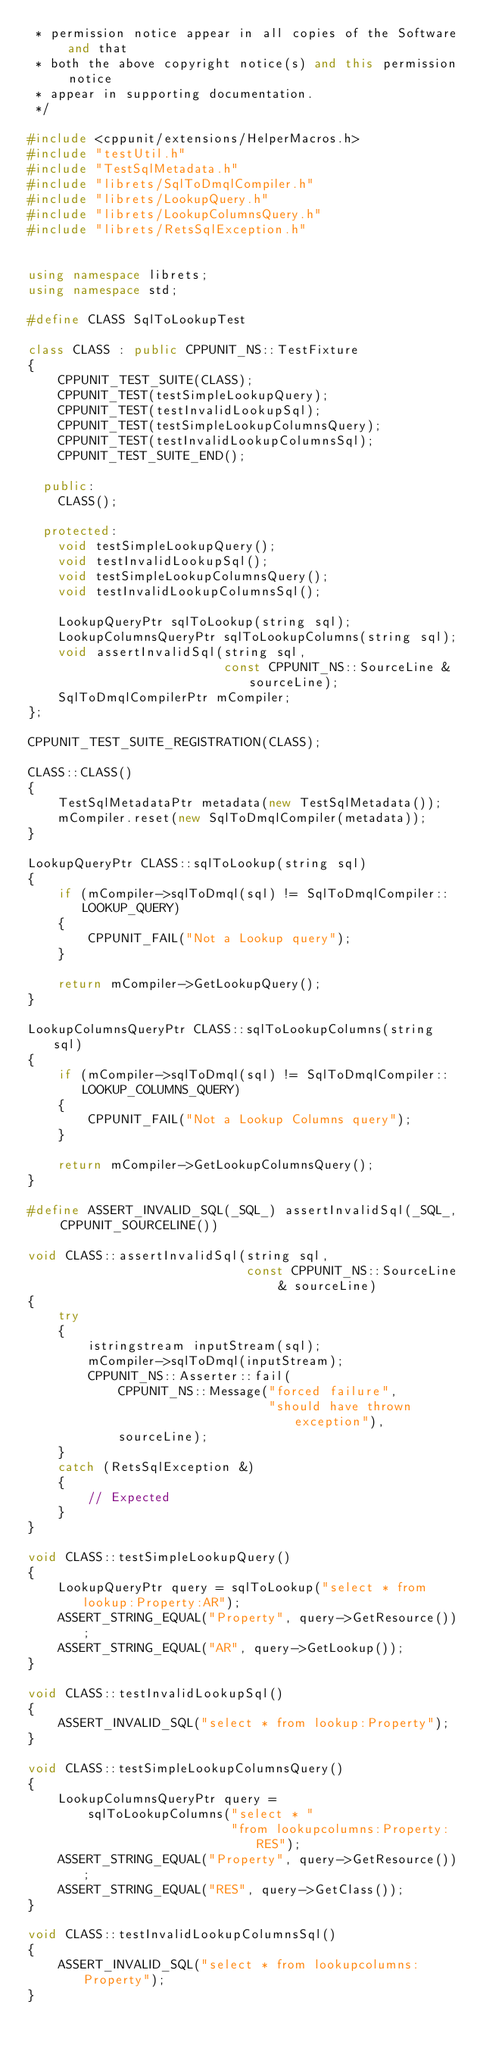Convert code to text. <code><loc_0><loc_0><loc_500><loc_500><_C++_> * permission notice appear in all copies of the Software and that
 * both the above copyright notice(s) and this permission notice
 * appear in supporting documentation.
 */

#include <cppunit/extensions/HelperMacros.h>
#include "testUtil.h"
#include "TestSqlMetadata.h"
#include "librets/SqlToDmqlCompiler.h"
#include "librets/LookupQuery.h"
#include "librets/LookupColumnsQuery.h"
#include "librets/RetsSqlException.h"


using namespace librets;
using namespace std;

#define CLASS SqlToLookupTest

class CLASS : public CPPUNIT_NS::TestFixture
{
    CPPUNIT_TEST_SUITE(CLASS);
    CPPUNIT_TEST(testSimpleLookupQuery);
    CPPUNIT_TEST(testInvalidLookupSql);
    CPPUNIT_TEST(testSimpleLookupColumnsQuery);
    CPPUNIT_TEST(testInvalidLookupColumnsSql);
    CPPUNIT_TEST_SUITE_END();

  public:
    CLASS();

  protected:
    void testSimpleLookupQuery();
    void testInvalidLookupSql();
    void testSimpleLookupColumnsQuery();
    void testInvalidLookupColumnsSql();
    
    LookupQueryPtr sqlToLookup(string sql);
    LookupColumnsQueryPtr sqlToLookupColumns(string sql);
    void assertInvalidSql(string sql,
                          const CPPUNIT_NS::SourceLine & sourceLine);
    SqlToDmqlCompilerPtr mCompiler;
};

CPPUNIT_TEST_SUITE_REGISTRATION(CLASS);

CLASS::CLASS()
{
    TestSqlMetadataPtr metadata(new TestSqlMetadata());
    mCompiler.reset(new SqlToDmqlCompiler(metadata));
}

LookupQueryPtr CLASS::sqlToLookup(string sql)
{
    if (mCompiler->sqlToDmql(sql) != SqlToDmqlCompiler::LOOKUP_QUERY)
    {
        CPPUNIT_FAIL("Not a Lookup query");
    }
    
    return mCompiler->GetLookupQuery();
}

LookupColumnsQueryPtr CLASS::sqlToLookupColumns(string sql)
{
    if (mCompiler->sqlToDmql(sql) != SqlToDmqlCompiler::LOOKUP_COLUMNS_QUERY)
    {
        CPPUNIT_FAIL("Not a Lookup Columns query");
    }
    
    return mCompiler->GetLookupColumnsQuery();
}

#define ASSERT_INVALID_SQL(_SQL_) assertInvalidSql(_SQL_, CPPUNIT_SOURCELINE())

void CLASS::assertInvalidSql(string sql,
                             const CPPUNIT_NS::SourceLine & sourceLine)
{
    try
    {
        istringstream inputStream(sql);
        mCompiler->sqlToDmql(inputStream);
        CPPUNIT_NS::Asserter::fail(
            CPPUNIT_NS::Message("forced failure",
                                "should have thrown exception"),
            sourceLine);
    }
    catch (RetsSqlException &)
    {
        // Expected
    }
}

void CLASS::testSimpleLookupQuery()
{
    LookupQueryPtr query = sqlToLookup("select * from lookup:Property:AR");
    ASSERT_STRING_EQUAL("Property", query->GetResource());
    ASSERT_STRING_EQUAL("AR", query->GetLookup());
}

void CLASS::testInvalidLookupSql()
{
    ASSERT_INVALID_SQL("select * from lookup:Property");
}

void CLASS::testSimpleLookupColumnsQuery()
{
    LookupColumnsQueryPtr query =
        sqlToLookupColumns("select * "
                           "from lookupcolumns:Property:RES");
    ASSERT_STRING_EQUAL("Property", query->GetResource());
    ASSERT_STRING_EQUAL("RES", query->GetClass());
}

void CLASS::testInvalidLookupColumnsSql()
{
    ASSERT_INVALID_SQL("select * from lookupcolumns:Property");
}
    
</code> 